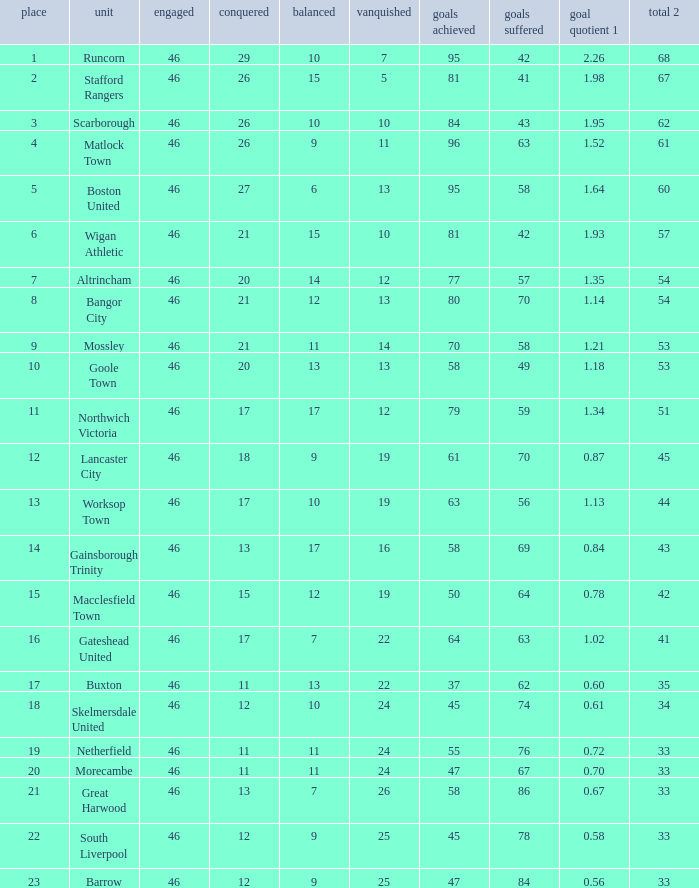Parse the full table. {'header': ['place', 'unit', 'engaged', 'conquered', 'balanced', 'vanquished', 'goals achieved', 'goals suffered', 'goal quotient 1', 'total 2'], 'rows': [['1', 'Runcorn', '46', '29', '10', '7', '95', '42', '2.26', '68'], ['2', 'Stafford Rangers', '46', '26', '15', '5', '81', '41', '1.98', '67'], ['3', 'Scarborough', '46', '26', '10', '10', '84', '43', '1.95', '62'], ['4', 'Matlock Town', '46', '26', '9', '11', '96', '63', '1.52', '61'], ['5', 'Boston United', '46', '27', '6', '13', '95', '58', '1.64', '60'], ['6', 'Wigan Athletic', '46', '21', '15', '10', '81', '42', '1.93', '57'], ['7', 'Altrincham', '46', '20', '14', '12', '77', '57', '1.35', '54'], ['8', 'Bangor City', '46', '21', '12', '13', '80', '70', '1.14', '54'], ['9', 'Mossley', '46', '21', '11', '14', '70', '58', '1.21', '53'], ['10', 'Goole Town', '46', '20', '13', '13', '58', '49', '1.18', '53'], ['11', 'Northwich Victoria', '46', '17', '17', '12', '79', '59', '1.34', '51'], ['12', 'Lancaster City', '46', '18', '9', '19', '61', '70', '0.87', '45'], ['13', 'Worksop Town', '46', '17', '10', '19', '63', '56', '1.13', '44'], ['14', 'Gainsborough Trinity', '46', '13', '17', '16', '58', '69', '0.84', '43'], ['15', 'Macclesfield Town', '46', '15', '12', '19', '50', '64', '0.78', '42'], ['16', 'Gateshead United', '46', '17', '7', '22', '64', '63', '1.02', '41'], ['17', 'Buxton', '46', '11', '13', '22', '37', '62', '0.60', '35'], ['18', 'Skelmersdale United', '46', '12', '10', '24', '45', '74', '0.61', '34'], ['19', 'Netherfield', '46', '11', '11', '24', '55', '76', '0.72', '33'], ['20', 'Morecambe', '46', '11', '11', '24', '47', '67', '0.70', '33'], ['21', 'Great Harwood', '46', '13', '7', '26', '58', '86', '0.67', '33'], ['22', 'South Liverpool', '46', '12', '9', '25', '45', '78', '0.58', '33'], ['23', 'Barrow', '46', '12', '9', '25', '47', '84', '0.56', '33']]} List all losses with average goals of 1.21. 14.0. 